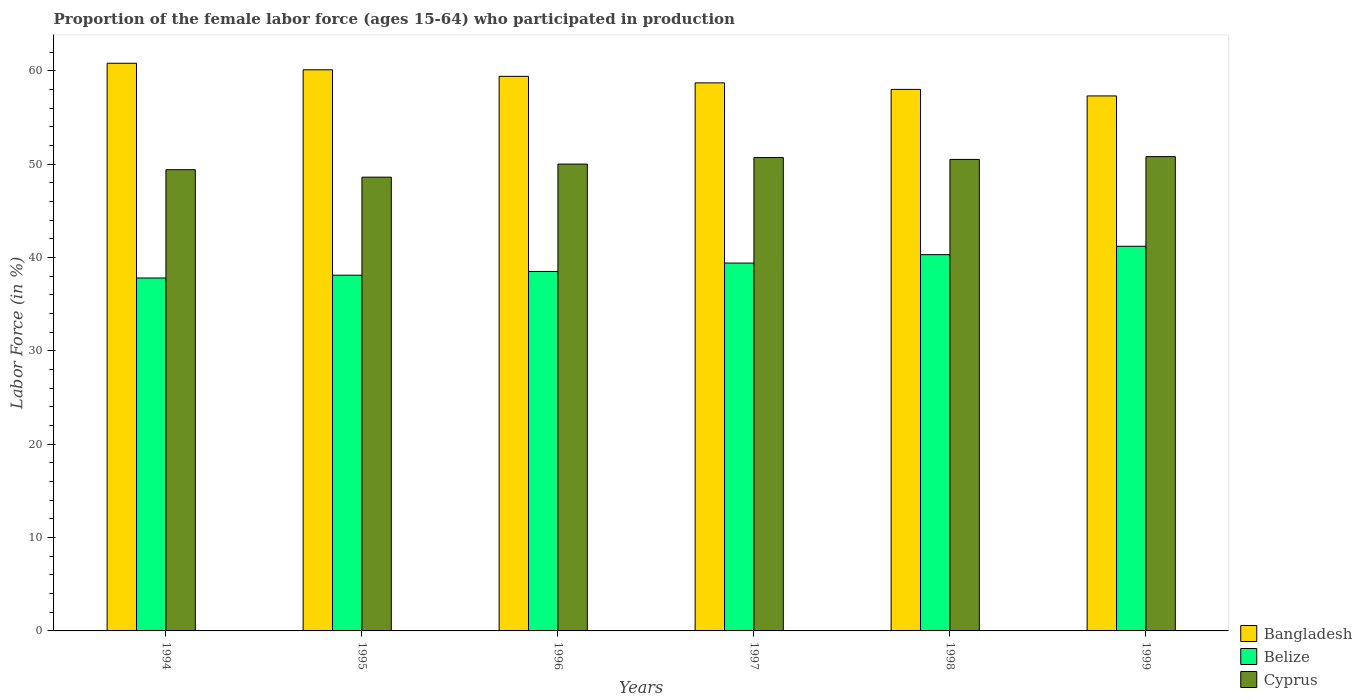How many different coloured bars are there?
Offer a very short reply. 3. Are the number of bars on each tick of the X-axis equal?
Your answer should be very brief. Yes. How many bars are there on the 2nd tick from the left?
Offer a very short reply. 3. How many bars are there on the 2nd tick from the right?
Provide a succinct answer. 3. What is the proportion of the female labor force who participated in production in Bangladesh in 1997?
Offer a very short reply. 58.7. Across all years, what is the maximum proportion of the female labor force who participated in production in Bangladesh?
Make the answer very short. 60.8. Across all years, what is the minimum proportion of the female labor force who participated in production in Belize?
Keep it short and to the point. 37.8. In which year was the proportion of the female labor force who participated in production in Cyprus minimum?
Offer a terse response. 1995. What is the total proportion of the female labor force who participated in production in Belize in the graph?
Provide a short and direct response. 235.3. What is the difference between the proportion of the female labor force who participated in production in Bangladesh in 1995 and that in 1999?
Make the answer very short. 2.8. What is the difference between the proportion of the female labor force who participated in production in Bangladesh in 1997 and the proportion of the female labor force who participated in production in Belize in 1996?
Your answer should be very brief. 20.2. What is the average proportion of the female labor force who participated in production in Bangladesh per year?
Ensure brevity in your answer.  59.05. In the year 1998, what is the difference between the proportion of the female labor force who participated in production in Cyprus and proportion of the female labor force who participated in production in Bangladesh?
Your response must be concise. -7.5. In how many years, is the proportion of the female labor force who participated in production in Cyprus greater than 14 %?
Offer a very short reply. 6. What is the ratio of the proportion of the female labor force who participated in production in Belize in 1996 to that in 1999?
Your answer should be very brief. 0.93. Is the proportion of the female labor force who participated in production in Cyprus in 1996 less than that in 1998?
Make the answer very short. Yes. What is the difference between the highest and the second highest proportion of the female labor force who participated in production in Cyprus?
Give a very brief answer. 0.1. What is the difference between the highest and the lowest proportion of the female labor force who participated in production in Belize?
Your answer should be very brief. 3.4. In how many years, is the proportion of the female labor force who participated in production in Bangladesh greater than the average proportion of the female labor force who participated in production in Bangladesh taken over all years?
Your answer should be very brief. 3. Is the sum of the proportion of the female labor force who participated in production in Belize in 1995 and 1999 greater than the maximum proportion of the female labor force who participated in production in Cyprus across all years?
Your answer should be compact. Yes. What does the 2nd bar from the left in 1994 represents?
Offer a terse response. Belize. What does the 1st bar from the right in 1996 represents?
Your answer should be compact. Cyprus. Is it the case that in every year, the sum of the proportion of the female labor force who participated in production in Belize and proportion of the female labor force who participated in production in Cyprus is greater than the proportion of the female labor force who participated in production in Bangladesh?
Keep it short and to the point. Yes. Are the values on the major ticks of Y-axis written in scientific E-notation?
Keep it short and to the point. No. Does the graph contain any zero values?
Your response must be concise. No. Does the graph contain grids?
Provide a short and direct response. No. How many legend labels are there?
Keep it short and to the point. 3. What is the title of the graph?
Provide a short and direct response. Proportion of the female labor force (ages 15-64) who participated in production. Does "Iceland" appear as one of the legend labels in the graph?
Provide a short and direct response. No. What is the label or title of the X-axis?
Make the answer very short. Years. What is the label or title of the Y-axis?
Your answer should be very brief. Labor Force (in %). What is the Labor Force (in %) of Bangladesh in 1994?
Your answer should be very brief. 60.8. What is the Labor Force (in %) of Belize in 1994?
Offer a terse response. 37.8. What is the Labor Force (in %) of Cyprus in 1994?
Provide a succinct answer. 49.4. What is the Labor Force (in %) of Bangladesh in 1995?
Make the answer very short. 60.1. What is the Labor Force (in %) of Belize in 1995?
Give a very brief answer. 38.1. What is the Labor Force (in %) in Cyprus in 1995?
Offer a terse response. 48.6. What is the Labor Force (in %) in Bangladesh in 1996?
Provide a succinct answer. 59.4. What is the Labor Force (in %) of Belize in 1996?
Your answer should be compact. 38.5. What is the Labor Force (in %) in Bangladesh in 1997?
Keep it short and to the point. 58.7. What is the Labor Force (in %) of Belize in 1997?
Provide a short and direct response. 39.4. What is the Labor Force (in %) in Cyprus in 1997?
Make the answer very short. 50.7. What is the Labor Force (in %) in Bangladesh in 1998?
Your answer should be very brief. 58. What is the Labor Force (in %) in Belize in 1998?
Provide a succinct answer. 40.3. What is the Labor Force (in %) of Cyprus in 1998?
Provide a succinct answer. 50.5. What is the Labor Force (in %) of Bangladesh in 1999?
Ensure brevity in your answer.  57.3. What is the Labor Force (in %) of Belize in 1999?
Your answer should be very brief. 41.2. What is the Labor Force (in %) of Cyprus in 1999?
Offer a very short reply. 50.8. Across all years, what is the maximum Labor Force (in %) in Bangladesh?
Keep it short and to the point. 60.8. Across all years, what is the maximum Labor Force (in %) of Belize?
Your response must be concise. 41.2. Across all years, what is the maximum Labor Force (in %) of Cyprus?
Provide a succinct answer. 50.8. Across all years, what is the minimum Labor Force (in %) of Bangladesh?
Your answer should be very brief. 57.3. Across all years, what is the minimum Labor Force (in %) of Belize?
Your answer should be compact. 37.8. Across all years, what is the minimum Labor Force (in %) of Cyprus?
Keep it short and to the point. 48.6. What is the total Labor Force (in %) of Bangladesh in the graph?
Your answer should be compact. 354.3. What is the total Labor Force (in %) of Belize in the graph?
Provide a short and direct response. 235.3. What is the total Labor Force (in %) of Cyprus in the graph?
Your response must be concise. 300. What is the difference between the Labor Force (in %) of Bangladesh in 1994 and that in 1995?
Keep it short and to the point. 0.7. What is the difference between the Labor Force (in %) of Bangladesh in 1994 and that in 1996?
Your answer should be very brief. 1.4. What is the difference between the Labor Force (in %) in Belize in 1994 and that in 1996?
Offer a very short reply. -0.7. What is the difference between the Labor Force (in %) of Belize in 1994 and that in 1997?
Provide a succinct answer. -1.6. What is the difference between the Labor Force (in %) in Bangladesh in 1994 and that in 1998?
Your response must be concise. 2.8. What is the difference between the Labor Force (in %) of Belize in 1994 and that in 1998?
Offer a terse response. -2.5. What is the difference between the Labor Force (in %) in Cyprus in 1994 and that in 1998?
Offer a very short reply. -1.1. What is the difference between the Labor Force (in %) of Bangladesh in 1995 and that in 1998?
Your response must be concise. 2.1. What is the difference between the Labor Force (in %) in Cyprus in 1995 and that in 1998?
Your response must be concise. -1.9. What is the difference between the Labor Force (in %) in Belize in 1995 and that in 1999?
Offer a terse response. -3.1. What is the difference between the Labor Force (in %) in Belize in 1996 and that in 1997?
Ensure brevity in your answer.  -0.9. What is the difference between the Labor Force (in %) of Cyprus in 1996 and that in 1997?
Your answer should be compact. -0.7. What is the difference between the Labor Force (in %) of Cyprus in 1996 and that in 1998?
Keep it short and to the point. -0.5. What is the difference between the Labor Force (in %) in Belize in 1996 and that in 1999?
Keep it short and to the point. -2.7. What is the difference between the Labor Force (in %) of Cyprus in 1997 and that in 1998?
Keep it short and to the point. 0.2. What is the difference between the Labor Force (in %) in Cyprus in 1997 and that in 1999?
Your response must be concise. -0.1. What is the difference between the Labor Force (in %) in Belize in 1998 and that in 1999?
Offer a very short reply. -0.9. What is the difference between the Labor Force (in %) of Bangladesh in 1994 and the Labor Force (in %) of Belize in 1995?
Make the answer very short. 22.7. What is the difference between the Labor Force (in %) in Bangladesh in 1994 and the Labor Force (in %) in Belize in 1996?
Your answer should be compact. 22.3. What is the difference between the Labor Force (in %) of Bangladesh in 1994 and the Labor Force (in %) of Cyprus in 1996?
Give a very brief answer. 10.8. What is the difference between the Labor Force (in %) of Bangladesh in 1994 and the Labor Force (in %) of Belize in 1997?
Give a very brief answer. 21.4. What is the difference between the Labor Force (in %) of Bangladesh in 1994 and the Labor Force (in %) of Belize in 1998?
Offer a terse response. 20.5. What is the difference between the Labor Force (in %) in Belize in 1994 and the Labor Force (in %) in Cyprus in 1998?
Your answer should be very brief. -12.7. What is the difference between the Labor Force (in %) of Bangladesh in 1994 and the Labor Force (in %) of Belize in 1999?
Give a very brief answer. 19.6. What is the difference between the Labor Force (in %) of Bangladesh in 1994 and the Labor Force (in %) of Cyprus in 1999?
Your answer should be very brief. 10. What is the difference between the Labor Force (in %) of Bangladesh in 1995 and the Labor Force (in %) of Belize in 1996?
Offer a very short reply. 21.6. What is the difference between the Labor Force (in %) of Bangladesh in 1995 and the Labor Force (in %) of Cyprus in 1996?
Your answer should be compact. 10.1. What is the difference between the Labor Force (in %) in Belize in 1995 and the Labor Force (in %) in Cyprus in 1996?
Provide a short and direct response. -11.9. What is the difference between the Labor Force (in %) in Bangladesh in 1995 and the Labor Force (in %) in Belize in 1997?
Provide a short and direct response. 20.7. What is the difference between the Labor Force (in %) of Belize in 1995 and the Labor Force (in %) of Cyprus in 1997?
Keep it short and to the point. -12.6. What is the difference between the Labor Force (in %) in Bangladesh in 1995 and the Labor Force (in %) in Belize in 1998?
Provide a short and direct response. 19.8. What is the difference between the Labor Force (in %) in Bangladesh in 1995 and the Labor Force (in %) in Cyprus in 1998?
Keep it short and to the point. 9.6. What is the difference between the Labor Force (in %) of Belize in 1995 and the Labor Force (in %) of Cyprus in 1998?
Give a very brief answer. -12.4. What is the difference between the Labor Force (in %) of Bangladesh in 1995 and the Labor Force (in %) of Cyprus in 1999?
Make the answer very short. 9.3. What is the difference between the Labor Force (in %) in Bangladesh in 1996 and the Labor Force (in %) in Cyprus in 1997?
Your answer should be very brief. 8.7. What is the difference between the Labor Force (in %) of Belize in 1996 and the Labor Force (in %) of Cyprus in 1997?
Provide a succinct answer. -12.2. What is the difference between the Labor Force (in %) of Bangladesh in 1996 and the Labor Force (in %) of Belize in 1998?
Your response must be concise. 19.1. What is the difference between the Labor Force (in %) in Belize in 1996 and the Labor Force (in %) in Cyprus in 1998?
Make the answer very short. -12. What is the difference between the Labor Force (in %) of Bangladesh in 1996 and the Labor Force (in %) of Cyprus in 1999?
Provide a short and direct response. 8.6. What is the difference between the Labor Force (in %) in Belize in 1996 and the Labor Force (in %) in Cyprus in 1999?
Provide a succinct answer. -12.3. What is the difference between the Labor Force (in %) of Bangladesh in 1997 and the Labor Force (in %) of Cyprus in 1998?
Ensure brevity in your answer.  8.2. What is the difference between the Labor Force (in %) in Bangladesh in 1997 and the Labor Force (in %) in Belize in 1999?
Keep it short and to the point. 17.5. What is the difference between the Labor Force (in %) of Bangladesh in 1997 and the Labor Force (in %) of Cyprus in 1999?
Offer a terse response. 7.9. What is the difference between the Labor Force (in %) of Belize in 1997 and the Labor Force (in %) of Cyprus in 1999?
Keep it short and to the point. -11.4. What is the difference between the Labor Force (in %) in Bangladesh in 1998 and the Labor Force (in %) in Belize in 1999?
Offer a terse response. 16.8. What is the average Labor Force (in %) of Bangladesh per year?
Ensure brevity in your answer.  59.05. What is the average Labor Force (in %) in Belize per year?
Your answer should be very brief. 39.22. In the year 1994, what is the difference between the Labor Force (in %) in Bangladesh and Labor Force (in %) in Belize?
Make the answer very short. 23. In the year 1994, what is the difference between the Labor Force (in %) of Belize and Labor Force (in %) of Cyprus?
Offer a terse response. -11.6. In the year 1995, what is the difference between the Labor Force (in %) in Bangladesh and Labor Force (in %) in Belize?
Ensure brevity in your answer.  22. In the year 1996, what is the difference between the Labor Force (in %) in Bangladesh and Labor Force (in %) in Belize?
Your answer should be very brief. 20.9. In the year 1997, what is the difference between the Labor Force (in %) of Bangladesh and Labor Force (in %) of Belize?
Ensure brevity in your answer.  19.3. In the year 1999, what is the difference between the Labor Force (in %) in Bangladesh and Labor Force (in %) in Cyprus?
Your answer should be compact. 6.5. In the year 1999, what is the difference between the Labor Force (in %) of Belize and Labor Force (in %) of Cyprus?
Make the answer very short. -9.6. What is the ratio of the Labor Force (in %) of Bangladesh in 1994 to that in 1995?
Make the answer very short. 1.01. What is the ratio of the Labor Force (in %) of Cyprus in 1994 to that in 1995?
Offer a terse response. 1.02. What is the ratio of the Labor Force (in %) of Bangladesh in 1994 to that in 1996?
Provide a short and direct response. 1.02. What is the ratio of the Labor Force (in %) in Belize in 1994 to that in 1996?
Provide a short and direct response. 0.98. What is the ratio of the Labor Force (in %) in Bangladesh in 1994 to that in 1997?
Provide a succinct answer. 1.04. What is the ratio of the Labor Force (in %) in Belize in 1994 to that in 1997?
Give a very brief answer. 0.96. What is the ratio of the Labor Force (in %) of Cyprus in 1994 to that in 1997?
Offer a terse response. 0.97. What is the ratio of the Labor Force (in %) in Bangladesh in 1994 to that in 1998?
Keep it short and to the point. 1.05. What is the ratio of the Labor Force (in %) of Belize in 1994 to that in 1998?
Offer a terse response. 0.94. What is the ratio of the Labor Force (in %) of Cyprus in 1994 to that in 1998?
Ensure brevity in your answer.  0.98. What is the ratio of the Labor Force (in %) of Bangladesh in 1994 to that in 1999?
Offer a very short reply. 1.06. What is the ratio of the Labor Force (in %) of Belize in 1994 to that in 1999?
Keep it short and to the point. 0.92. What is the ratio of the Labor Force (in %) of Cyprus in 1994 to that in 1999?
Your answer should be very brief. 0.97. What is the ratio of the Labor Force (in %) of Bangladesh in 1995 to that in 1996?
Give a very brief answer. 1.01. What is the ratio of the Labor Force (in %) in Belize in 1995 to that in 1996?
Keep it short and to the point. 0.99. What is the ratio of the Labor Force (in %) in Cyprus in 1995 to that in 1996?
Provide a succinct answer. 0.97. What is the ratio of the Labor Force (in %) in Bangladesh in 1995 to that in 1997?
Your answer should be compact. 1.02. What is the ratio of the Labor Force (in %) of Cyprus in 1995 to that in 1997?
Give a very brief answer. 0.96. What is the ratio of the Labor Force (in %) in Bangladesh in 1995 to that in 1998?
Your answer should be compact. 1.04. What is the ratio of the Labor Force (in %) in Belize in 1995 to that in 1998?
Ensure brevity in your answer.  0.95. What is the ratio of the Labor Force (in %) of Cyprus in 1995 to that in 1998?
Give a very brief answer. 0.96. What is the ratio of the Labor Force (in %) of Bangladesh in 1995 to that in 1999?
Make the answer very short. 1.05. What is the ratio of the Labor Force (in %) in Belize in 1995 to that in 1999?
Your answer should be very brief. 0.92. What is the ratio of the Labor Force (in %) in Cyprus in 1995 to that in 1999?
Your answer should be very brief. 0.96. What is the ratio of the Labor Force (in %) of Bangladesh in 1996 to that in 1997?
Keep it short and to the point. 1.01. What is the ratio of the Labor Force (in %) of Belize in 1996 to that in 1997?
Provide a short and direct response. 0.98. What is the ratio of the Labor Force (in %) of Cyprus in 1996 to that in 1997?
Your answer should be very brief. 0.99. What is the ratio of the Labor Force (in %) of Bangladesh in 1996 to that in 1998?
Keep it short and to the point. 1.02. What is the ratio of the Labor Force (in %) of Belize in 1996 to that in 1998?
Offer a terse response. 0.96. What is the ratio of the Labor Force (in %) in Bangladesh in 1996 to that in 1999?
Offer a very short reply. 1.04. What is the ratio of the Labor Force (in %) in Belize in 1996 to that in 1999?
Provide a short and direct response. 0.93. What is the ratio of the Labor Force (in %) in Cyprus in 1996 to that in 1999?
Ensure brevity in your answer.  0.98. What is the ratio of the Labor Force (in %) of Bangladesh in 1997 to that in 1998?
Ensure brevity in your answer.  1.01. What is the ratio of the Labor Force (in %) of Belize in 1997 to that in 1998?
Keep it short and to the point. 0.98. What is the ratio of the Labor Force (in %) of Cyprus in 1997 to that in 1998?
Give a very brief answer. 1. What is the ratio of the Labor Force (in %) of Bangladesh in 1997 to that in 1999?
Ensure brevity in your answer.  1.02. What is the ratio of the Labor Force (in %) of Belize in 1997 to that in 1999?
Give a very brief answer. 0.96. What is the ratio of the Labor Force (in %) of Bangladesh in 1998 to that in 1999?
Provide a short and direct response. 1.01. What is the ratio of the Labor Force (in %) in Belize in 1998 to that in 1999?
Offer a terse response. 0.98. What is the difference between the highest and the second highest Labor Force (in %) of Bangladesh?
Give a very brief answer. 0.7. What is the difference between the highest and the second highest Labor Force (in %) of Belize?
Your answer should be very brief. 0.9. What is the difference between the highest and the lowest Labor Force (in %) of Belize?
Your answer should be compact. 3.4. 